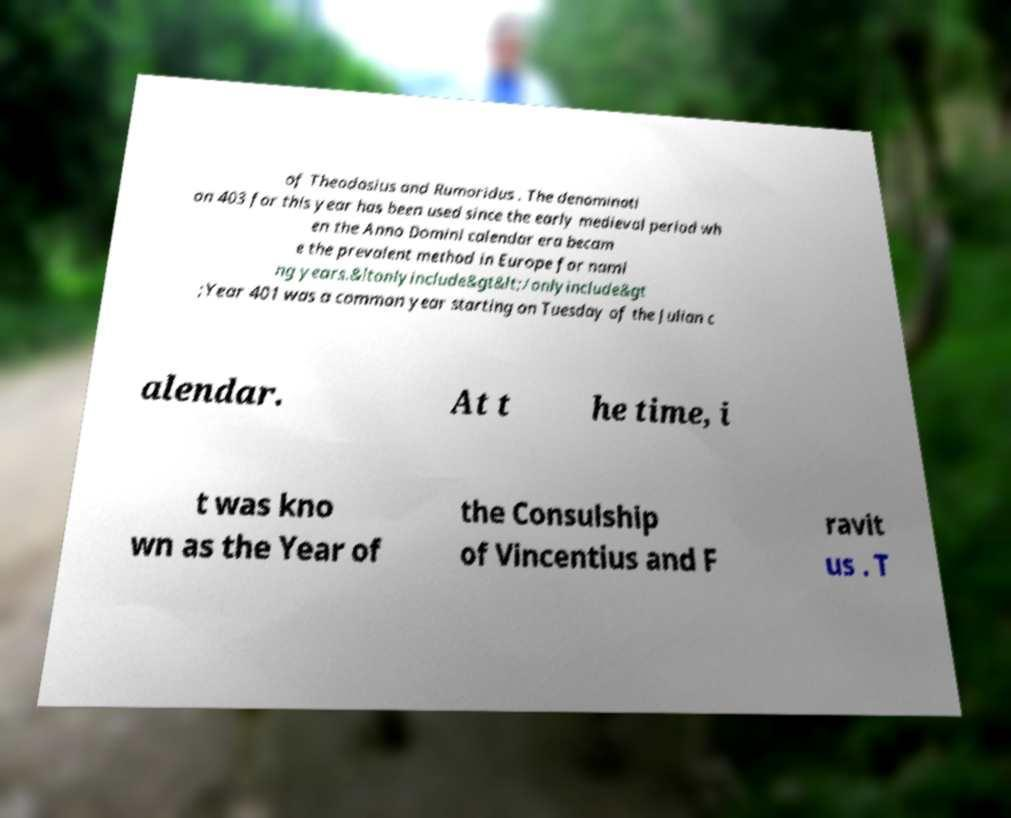Could you extract and type out the text from this image? of Theodosius and Rumoridus . The denominati on 403 for this year has been used since the early medieval period wh en the Anno Domini calendar era becam e the prevalent method in Europe for nami ng years.&ltonlyinclude&gt&lt;/onlyinclude&gt ;Year 401 was a common year starting on Tuesday of the Julian c alendar. At t he time, i t was kno wn as the Year of the Consulship of Vincentius and F ravit us . T 